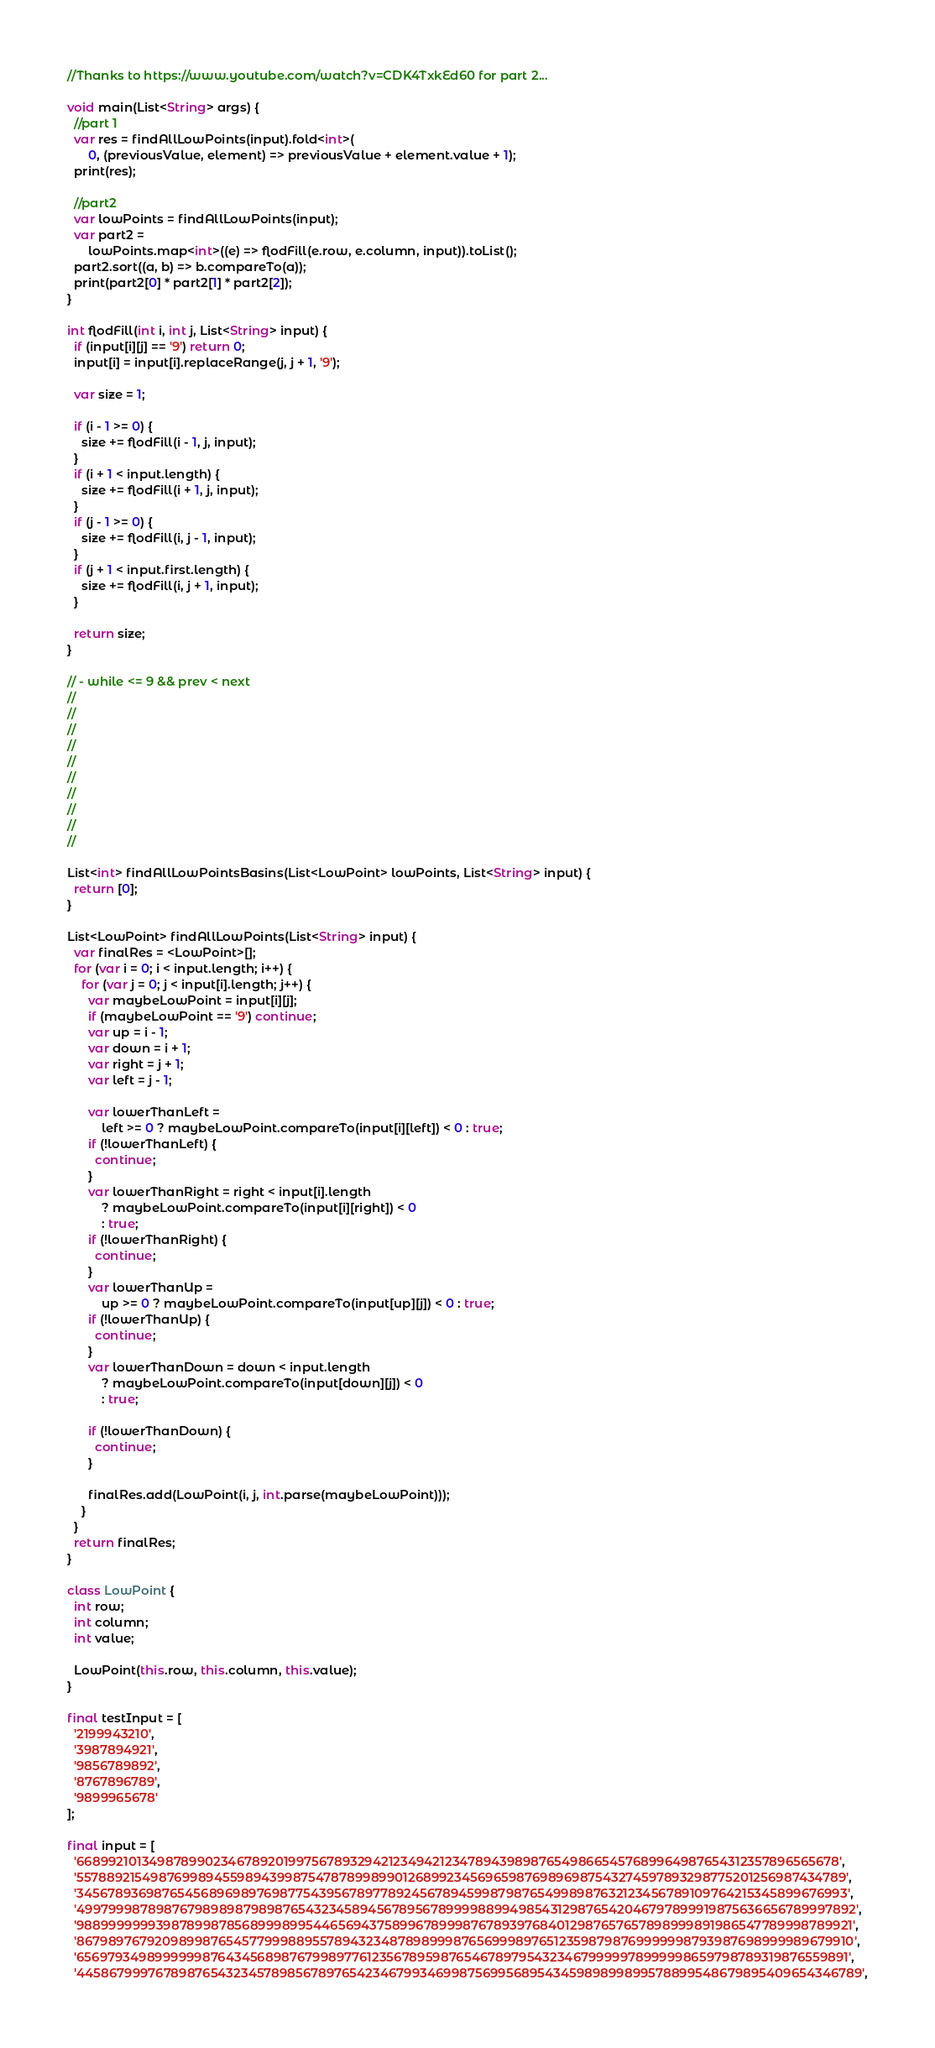Convert code to text. <code><loc_0><loc_0><loc_500><loc_500><_Dart_>//Thanks to https://www.youtube.com/watch?v=CDK4TxkEd60 for part 2...

void main(List<String> args) {
  //part 1
  var res = findAllLowPoints(input).fold<int>(
      0, (previousValue, element) => previousValue + element.value + 1);
  print(res);

  //part2
  var lowPoints = findAllLowPoints(input);
  var part2 =
      lowPoints.map<int>((e) => flodFill(e.row, e.column, input)).toList();
  part2.sort((a, b) => b.compareTo(a));
  print(part2[0] * part2[1] * part2[2]);
}

int flodFill(int i, int j, List<String> input) {
  if (input[i][j] == '9') return 0;
  input[i] = input[i].replaceRange(j, j + 1, '9');

  var size = 1;

  if (i - 1 >= 0) {
    size += flodFill(i - 1, j, input);
  }
  if (i + 1 < input.length) {
    size += flodFill(i + 1, j, input);
  }
  if (j - 1 >= 0) {
    size += flodFill(i, j - 1, input);
  }
  if (j + 1 < input.first.length) {
    size += flodFill(i, j + 1, input);
  }

  return size;
}

// - while <= 9 && prev < next
//
//
//
//
//
//
//
//
//
//

List<int> findAllLowPointsBasins(List<LowPoint> lowPoints, List<String> input) {
  return [0];
}

List<LowPoint> findAllLowPoints(List<String> input) {
  var finalRes = <LowPoint>[];
  for (var i = 0; i < input.length; i++) {
    for (var j = 0; j < input[i].length; j++) {
      var maybeLowPoint = input[i][j];
      if (maybeLowPoint == '9') continue;
      var up = i - 1;
      var down = i + 1;
      var right = j + 1;
      var left = j - 1;

      var lowerThanLeft =
          left >= 0 ? maybeLowPoint.compareTo(input[i][left]) < 0 : true;
      if (!lowerThanLeft) {
        continue;
      }
      var lowerThanRight = right < input[i].length
          ? maybeLowPoint.compareTo(input[i][right]) < 0
          : true;
      if (!lowerThanRight) {
        continue;
      }
      var lowerThanUp =
          up >= 0 ? maybeLowPoint.compareTo(input[up][j]) < 0 : true;
      if (!lowerThanUp) {
        continue;
      }
      var lowerThanDown = down < input.length
          ? maybeLowPoint.compareTo(input[down][j]) < 0
          : true;

      if (!lowerThanDown) {
        continue;
      }

      finalRes.add(LowPoint(i, j, int.parse(maybeLowPoint)));
    }
  }
  return finalRes;
}

class LowPoint {
  int row;
  int column;
  int value;

  LowPoint(this.row, this.column, this.value);
}

final testInput = [
  '2199943210',
  '3987894921',
  '9856789892',
  '8767896789',
  '9899965678'
];

final input = [
  '6689921013498789902346789201997567893294212349421234789439898765498665457689964987654312357896565678',
  '5578892154987699894559894399875478789989901268992345696598769896987543274597893298775201256987434789',
  '3456789369876545689698976987754395678977892456789459987987654998987632123456789109764215345899676993',
  '4997999878987679898987989876543234589456789567899998899498543129876542046797899919875636656789997892',
  '9889999999398789987856899989954465694375899678999876789397684012987657657898999891986547789998789921',
  '8679897679209899876545779998895578943234878989998765699989765123598798769999998793987698999989679910',
  '6569793498999999876434568987679989776123567895987654678979543234679999978999998659798789319876559891',
  '4458679997678987654323457898567897654234679934699875699568954345989899899578899548679895409654346789',</code> 